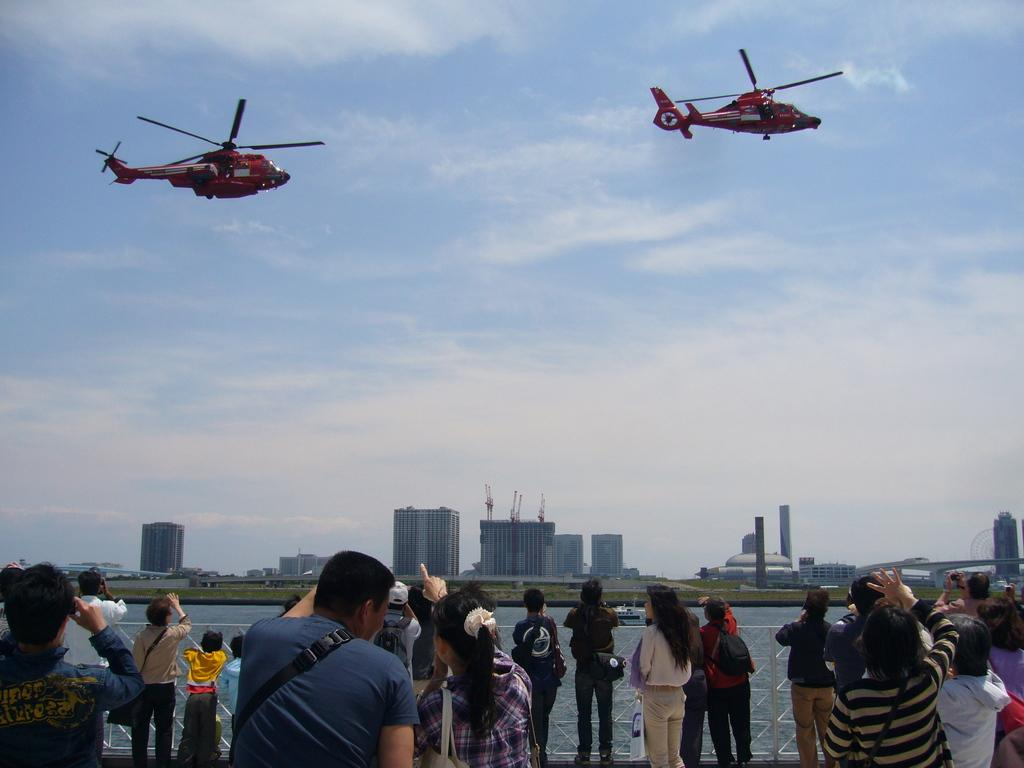What are the people doing in the image? The people are standing in front of grills. What can be seen in the sky in the image? There are planes in the air. What is visible in the image that might indicate a location? There is water, buildings, and trees visible in the image. What type of pet can be seen in the image? There is no pet visible in the image. 